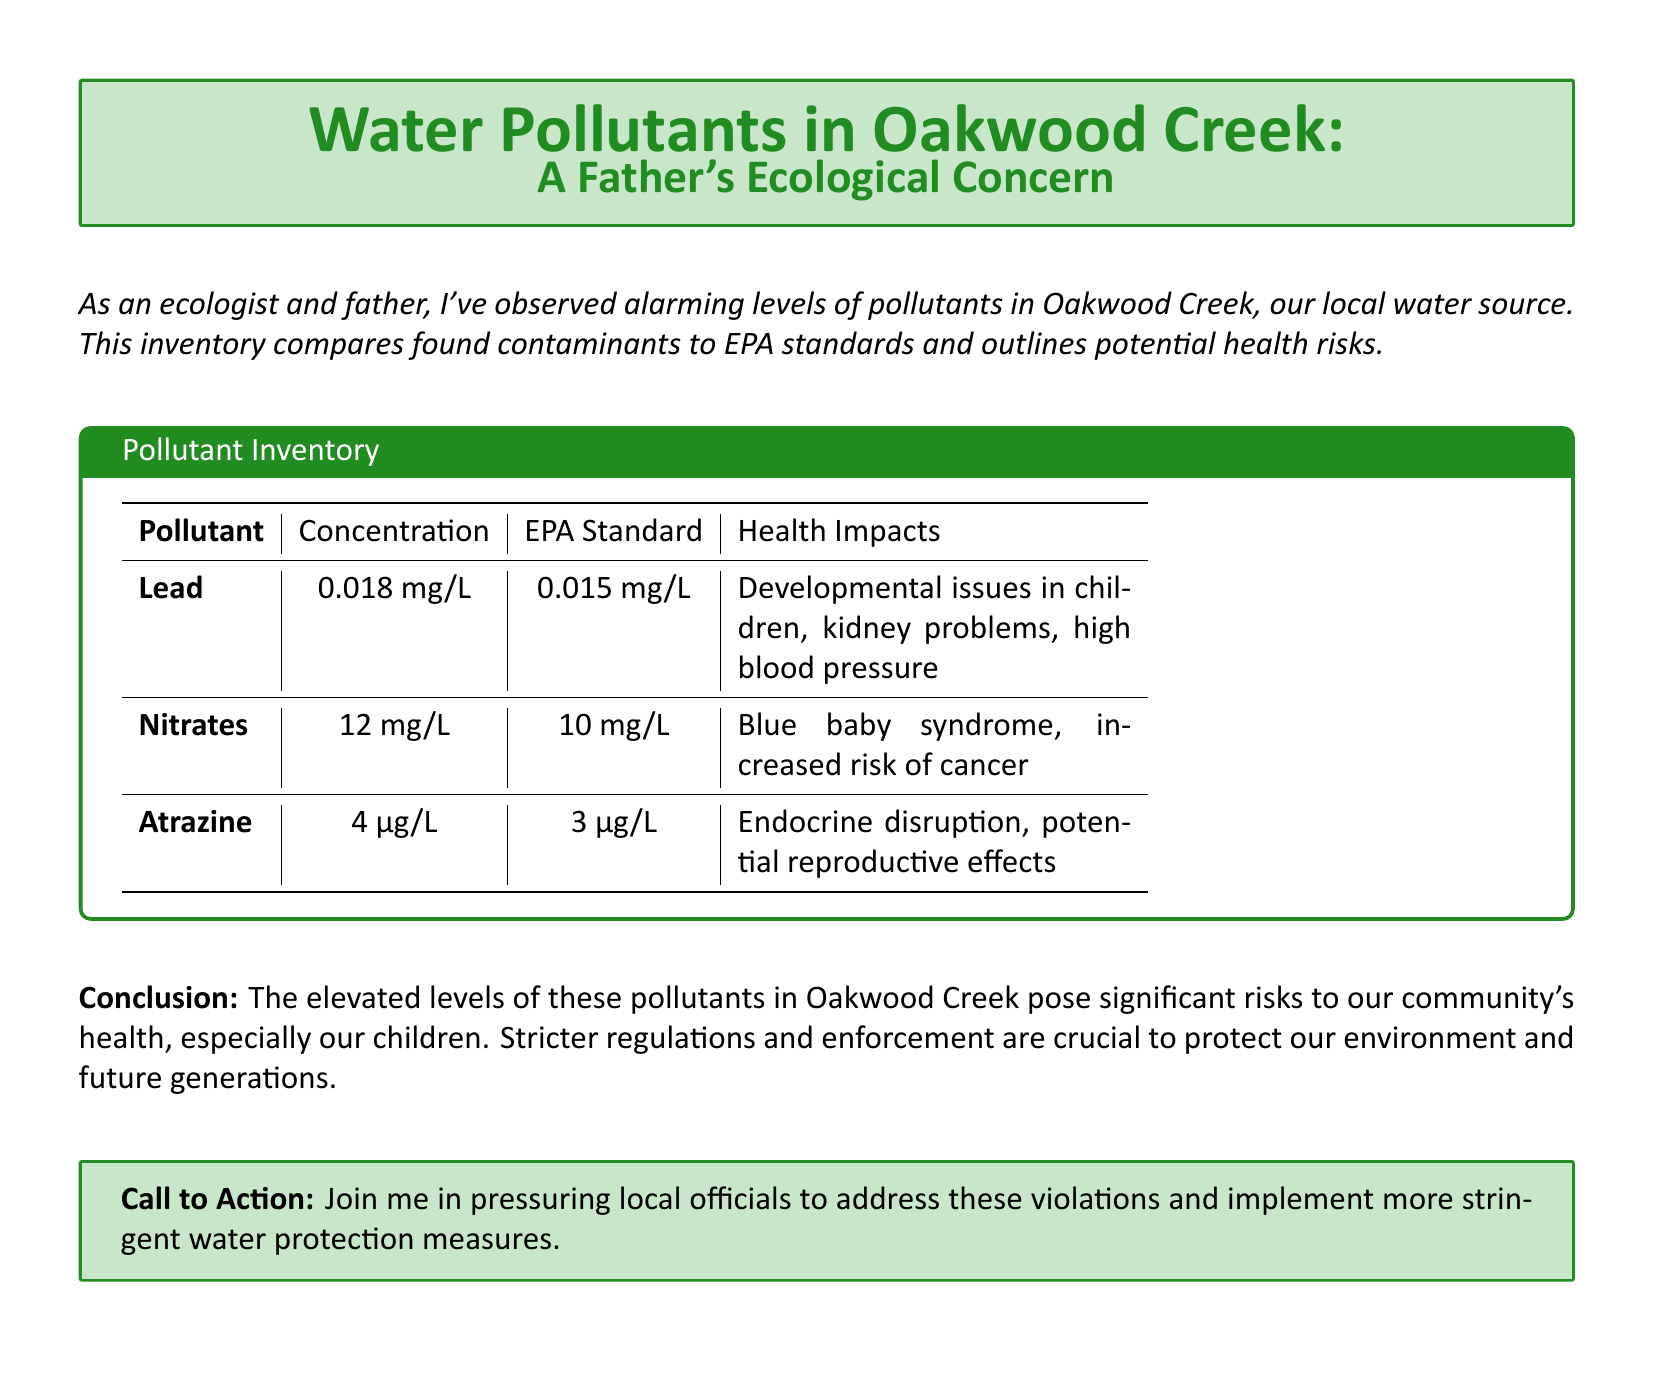What is the primary focus of the document? The document highlights the levels of pollutants in Oakwood Creek and their impact on health, particularly for children.
Answer: Water pollutants What is the concentration of Lead found in Oakwood Creek? The concentration listed in the document for Lead is indicated in the table.
Answer: 0.018 mg/L What is the EPA standard for Nitrates? The EPA standard for Nitrates is stated clearly in the table, comparing it to the detected concentration.
Answer: 10 mg/L What health impact is associated with Atrazine exposure? The potential health impacts of Atrazine are summarized in the inventory table.
Answer: Endocrine disruption Which pollutant has the highest concentration compared to its EPA standard? This question requires a comparison of the contaminant concentrations with their respective EPA standards provided in the table.
Answer: Nitrates What health risk is particularly mentioned for children in the document? The document specifies a concerning health risk that is emphasized for children.
Answer: Developmental issues What is the call to action in the document? The document concludes with a community engagement request regarding local environmental issues.
Answer: Pressure local officials How many pollutants are listed in the inventory? The total number of pollutants can be counted from the inventory presented.
Answer: 3 